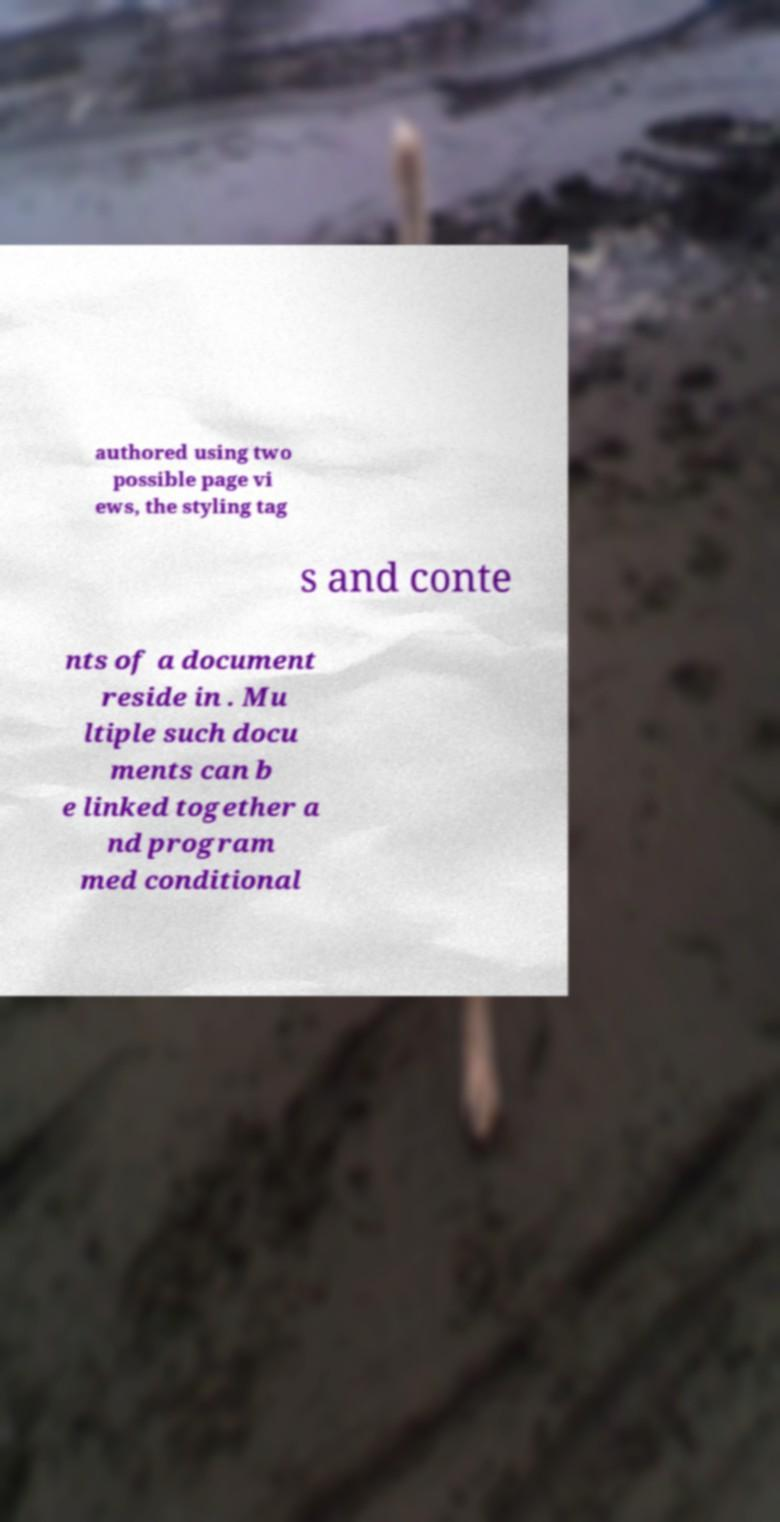Please read and relay the text visible in this image. What does it say? authored using two possible page vi ews, the styling tag s and conte nts of a document reside in . Mu ltiple such docu ments can b e linked together a nd program med conditional 